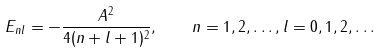Convert formula to latex. <formula><loc_0><loc_0><loc_500><loc_500>E _ { n l } = - \frac { A ^ { 2 } } { 4 ( n + l + 1 ) ^ { 2 } } , \quad n = 1 , 2 , \dots , l = 0 , 1 , 2 , \dots</formula> 